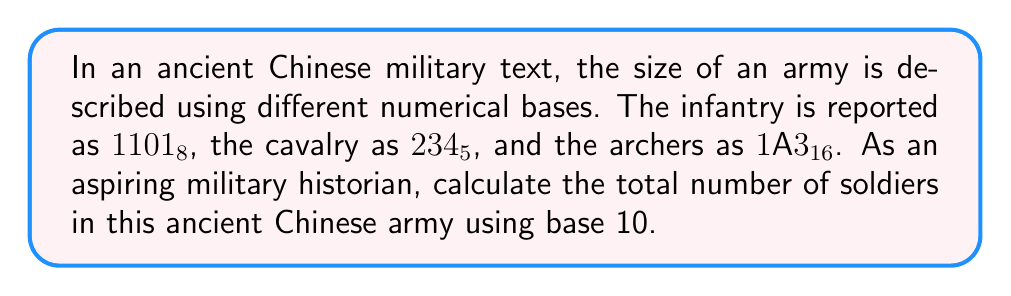Show me your answer to this math problem. To solve this problem, we need to convert each number from its given base to base 10 and then sum the results.

1. Infantry (base 8 to base 10):
   $1101_8 = 1 \times 8^3 + 1 \times 8^2 + 0 \times 8^1 + 1 \times 8^0$
   $= 1 \times 512 + 1 \times 64 + 0 \times 8 + 1 \times 1$
   $= 512 + 64 + 0 + 1 = 577_{10}$

2. Cavalry (base 5 to base 10):
   $234_5 = 2 \times 5^2 + 3 \times 5^1 + 4 \times 5^0$
   $= 2 \times 25 + 3 \times 5 + 4 \times 1$
   $= 50 + 15 + 4 = 69_{10}$

3. Archers (base 16 to base 10):
   In base 16, A represents 10.
   $1A3_{16} = 1 \times 16^2 + 10 \times 16^1 + 3 \times 16^0$
   $= 1 \times 256 + 10 \times 16 + 3 \times 1$
   $= 256 + 160 + 3 = 419_{10}$

Now, we sum up the converted numbers:
$577 + 69 + 419 = 1065$

Therefore, the total number of soldiers in the ancient Chinese army is 1065 in base 10.
Answer: 1065 soldiers 